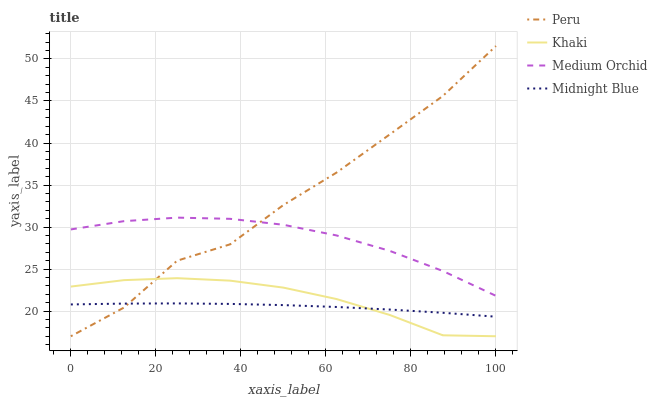Does Midnight Blue have the minimum area under the curve?
Answer yes or no. Yes. Does Peru have the maximum area under the curve?
Answer yes or no. Yes. Does Khaki have the minimum area under the curve?
Answer yes or no. No. Does Khaki have the maximum area under the curve?
Answer yes or no. No. Is Midnight Blue the smoothest?
Answer yes or no. Yes. Is Peru the roughest?
Answer yes or no. Yes. Is Khaki the smoothest?
Answer yes or no. No. Is Khaki the roughest?
Answer yes or no. No. Does Midnight Blue have the lowest value?
Answer yes or no. No. Does Peru have the highest value?
Answer yes or no. Yes. Does Khaki have the highest value?
Answer yes or no. No. Is Khaki less than Medium Orchid?
Answer yes or no. Yes. Is Medium Orchid greater than Khaki?
Answer yes or no. Yes. Does Peru intersect Medium Orchid?
Answer yes or no. Yes. Is Peru less than Medium Orchid?
Answer yes or no. No. Is Peru greater than Medium Orchid?
Answer yes or no. No. Does Khaki intersect Medium Orchid?
Answer yes or no. No. 